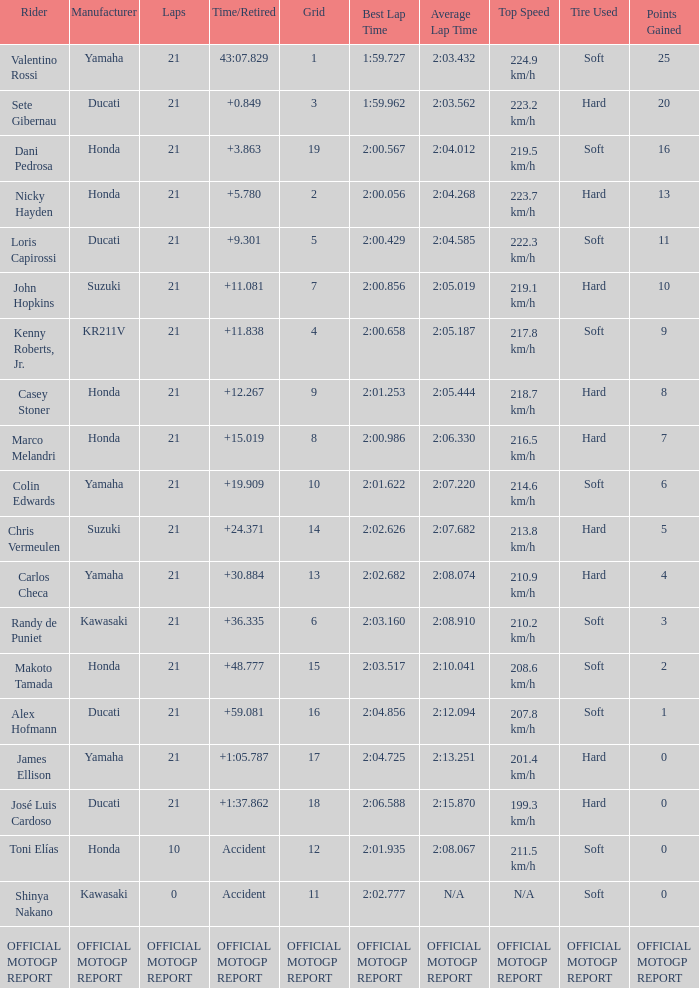When rider John Hopkins had 21 laps, what was the grid? 7.0. 